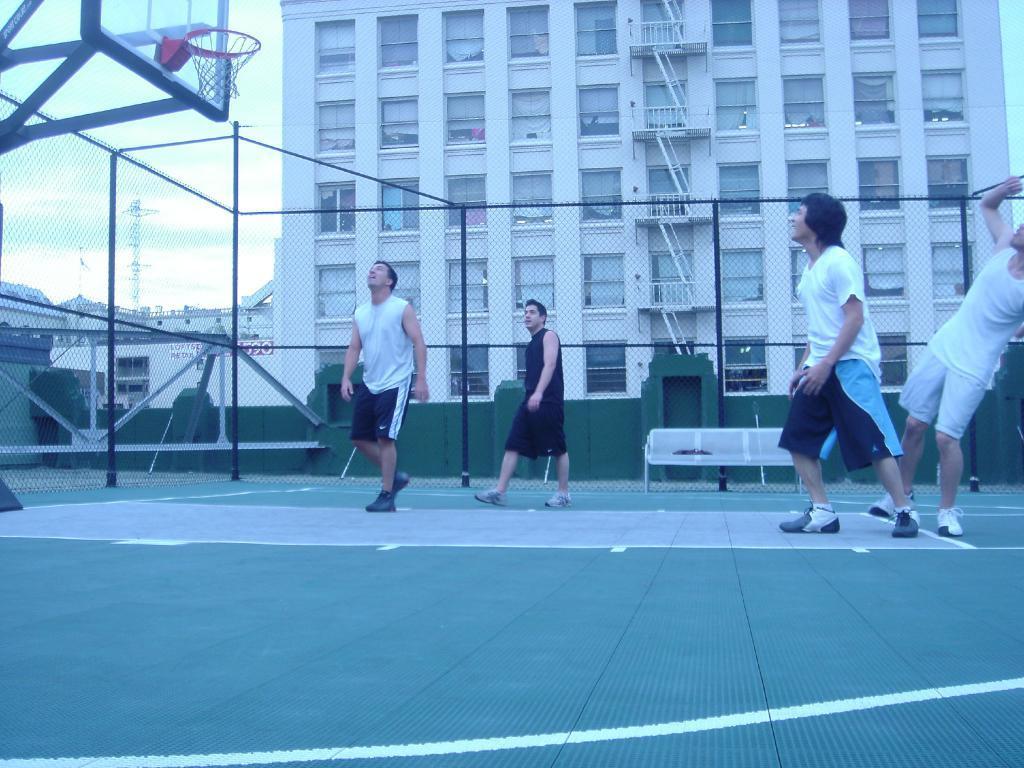In one or two sentences, can you explain what this image depicts? In this image we can see a group of men on the ground. We can also see a metal fence, a bench, some poles and a goal post. On the backside we can see some buildings with windows, a board with some text on it, a tower and the sky which looks cloudy. 